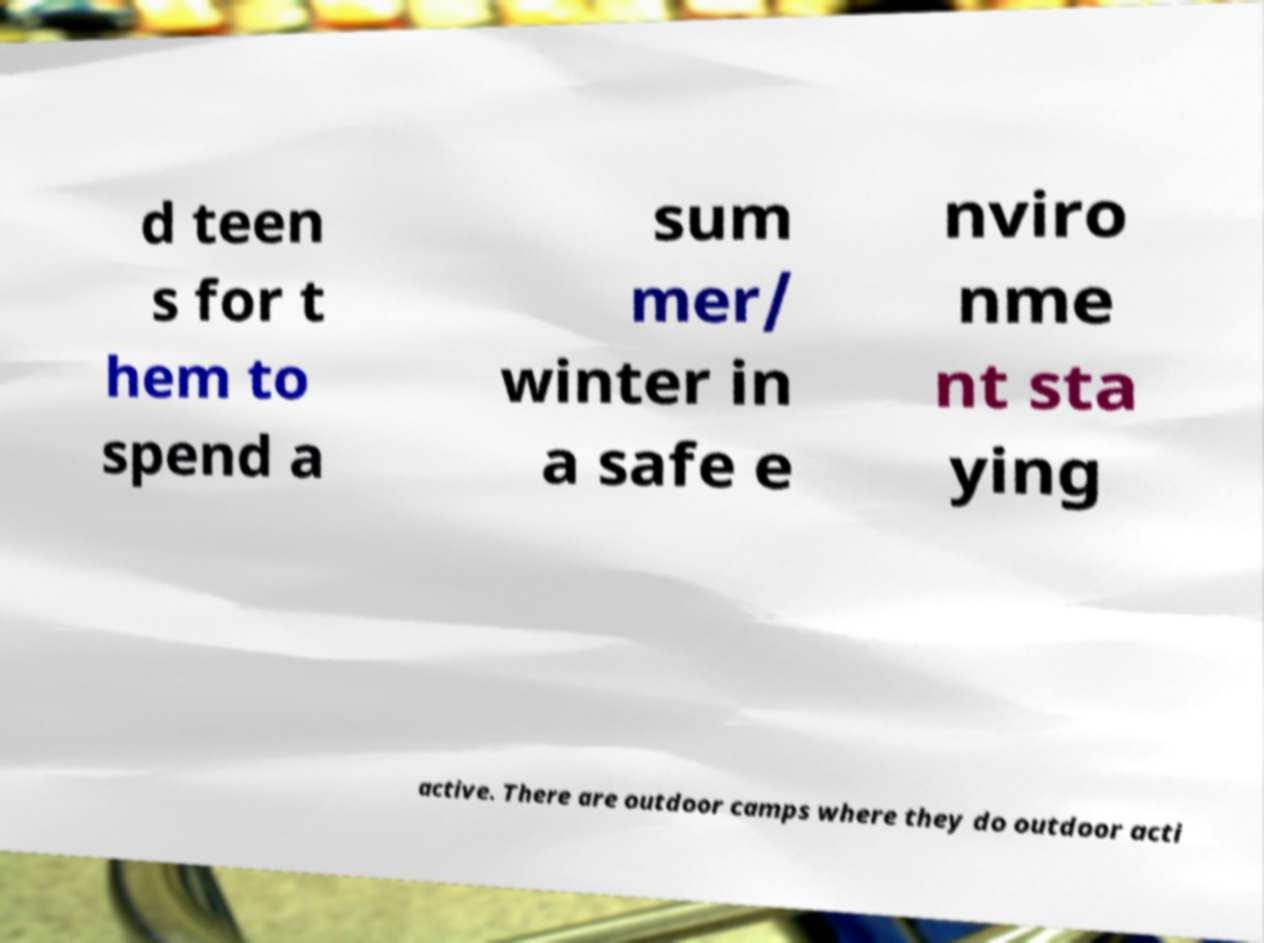I need the written content from this picture converted into text. Can you do that? d teen s for t hem to spend a sum mer/ winter in a safe e nviro nme nt sta ying active. There are outdoor camps where they do outdoor acti 